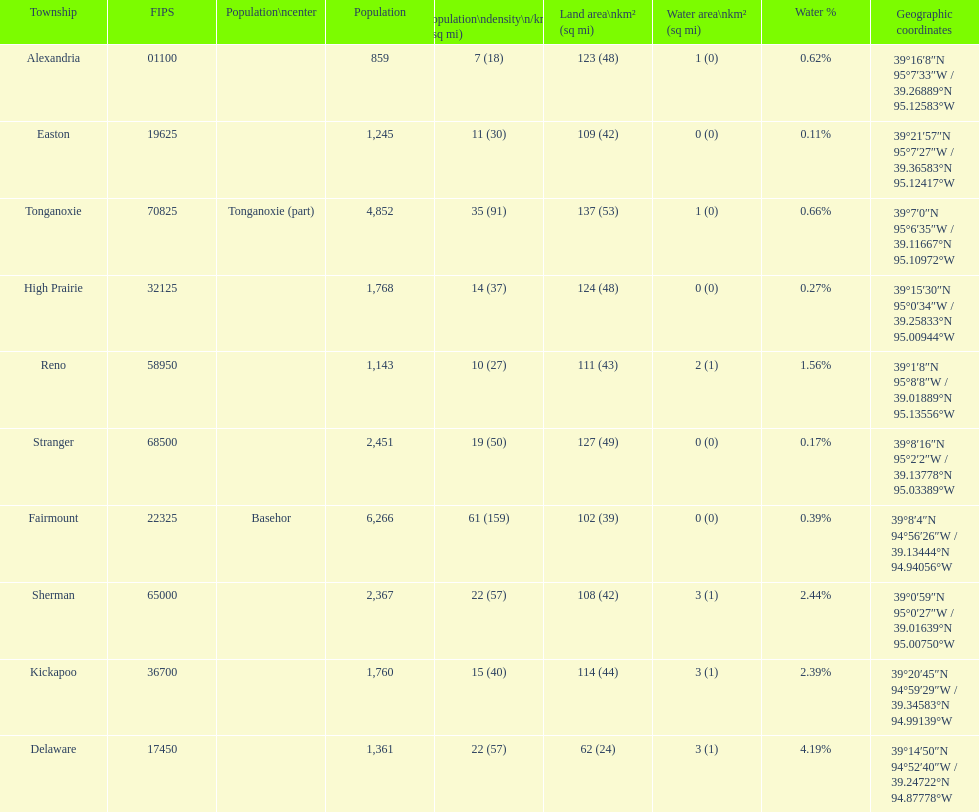Which township has the least land area? Delaware. 